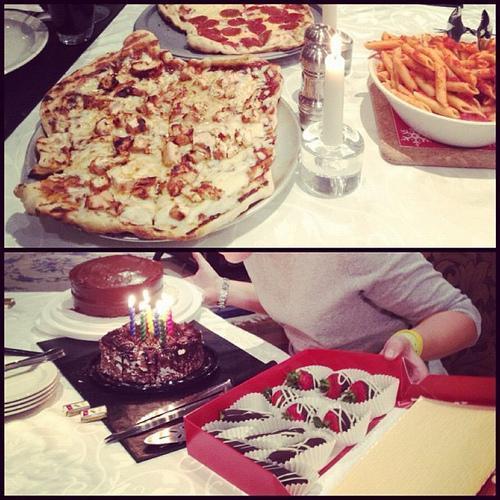How many pizzas are there?
Give a very brief answer. 2. How many chocolate covered strawberries are there?
Give a very brief answer. 6. 